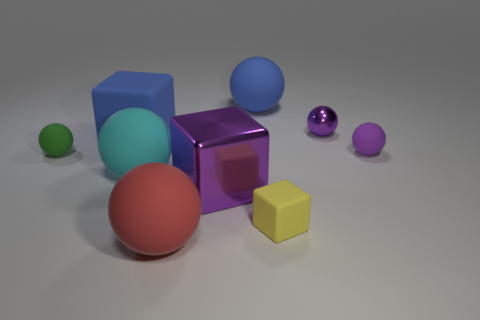The big metal thing that is the same color as the tiny metallic ball is what shape?
Your answer should be compact. Cube. There is a green rubber object that is the same size as the yellow block; what shape is it?
Provide a short and direct response. Sphere. The large blue object on the right side of the rubber cube on the left side of the sphere that is in front of the yellow matte block is what shape?
Give a very brief answer. Sphere. Does the green object have the same shape as the blue rubber object right of the red object?
Keep it short and to the point. Yes. What number of large objects are either red matte spheres or gray rubber cubes?
Offer a very short reply. 1. Is there another green ball that has the same size as the green rubber ball?
Ensure brevity in your answer.  No. There is a large rubber ball behind the small purple object that is in front of the blue object that is on the left side of the blue rubber ball; what color is it?
Provide a succinct answer. Blue. Do the large blue sphere and the small ball on the left side of the yellow object have the same material?
Your answer should be very brief. Yes. There is a red matte thing that is the same shape as the cyan rubber object; what size is it?
Give a very brief answer. Large. Are there the same number of metal things that are on the left side of the tiny green sphere and big blue rubber cubes that are to the right of the cyan matte object?
Keep it short and to the point. Yes. 